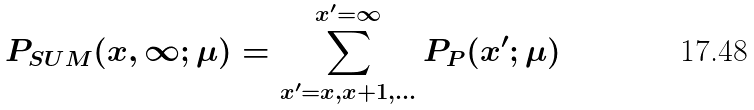Convert formula to latex. <formula><loc_0><loc_0><loc_500><loc_500>P _ { S U M } ( x , \infty ; \mu ) = \sum _ { x ^ { \prime } = x , x + 1 , \dots } ^ { x ^ { \prime } = \infty } P _ { P } ( x ^ { \prime } ; \mu )</formula> 